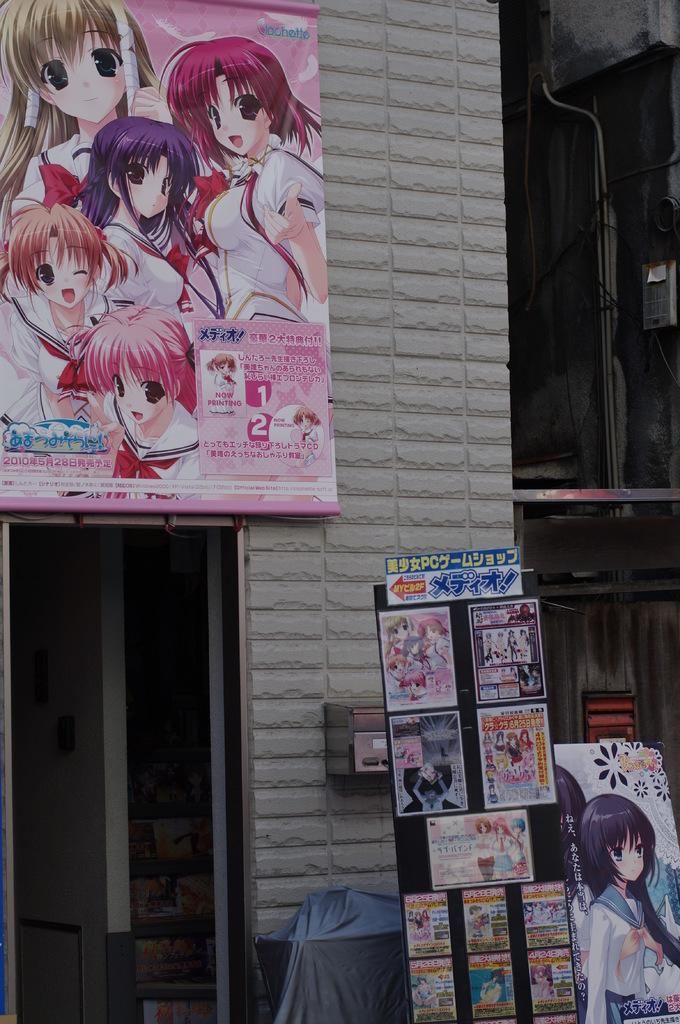What can be seen on the sides of the road in the image? There are hoardings in the image. What is visible in the distance in the image? There is a building in the background of the image. Is there a spark visible in the image? There is no mention of a spark in the provided facts, and therefore it cannot be determined if one is present in the image. 